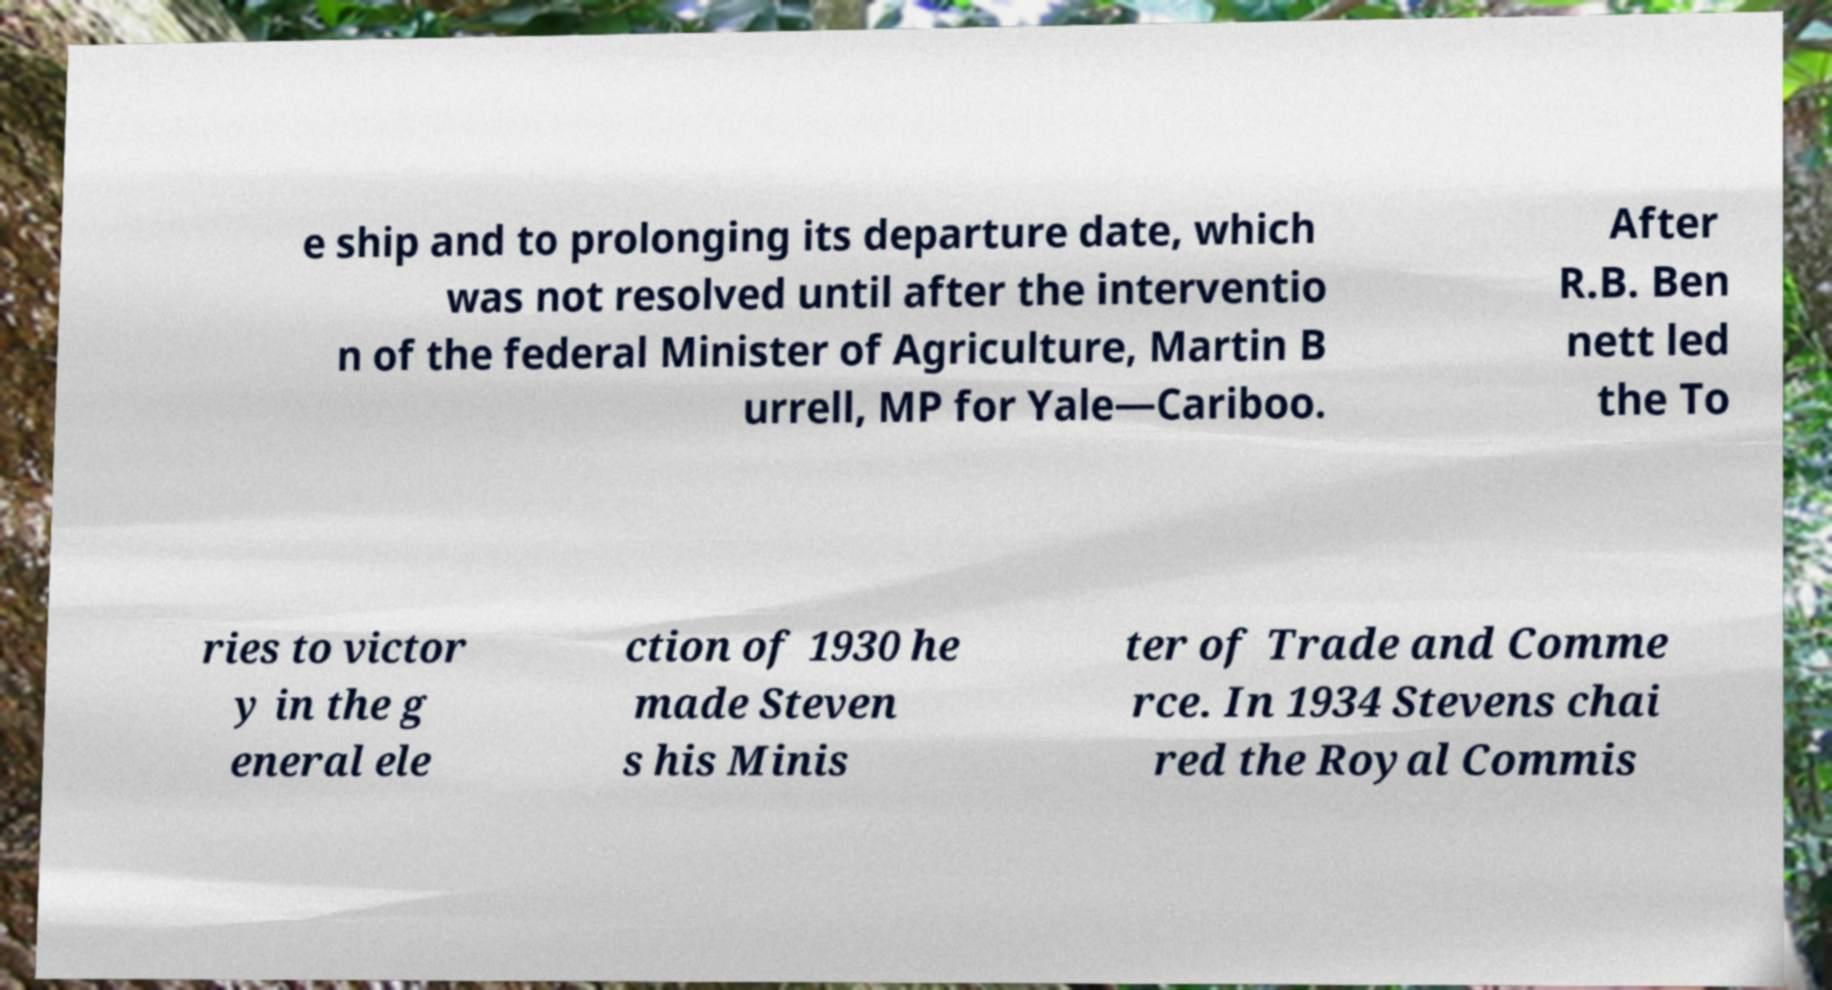Please identify and transcribe the text found in this image. e ship and to prolonging its departure date, which was not resolved until after the interventio n of the federal Minister of Agriculture, Martin B urrell, MP for Yale—Cariboo. After R.B. Ben nett led the To ries to victor y in the g eneral ele ction of 1930 he made Steven s his Minis ter of Trade and Comme rce. In 1934 Stevens chai red the Royal Commis 